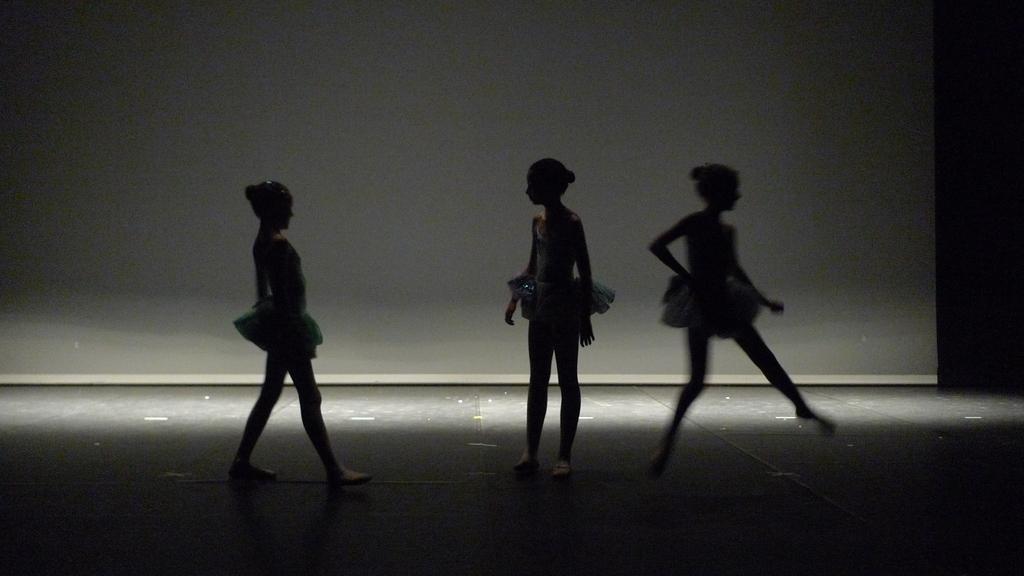Can you describe this image briefly? In this image there are persons standing and in the background there is a board which is white in colour. 